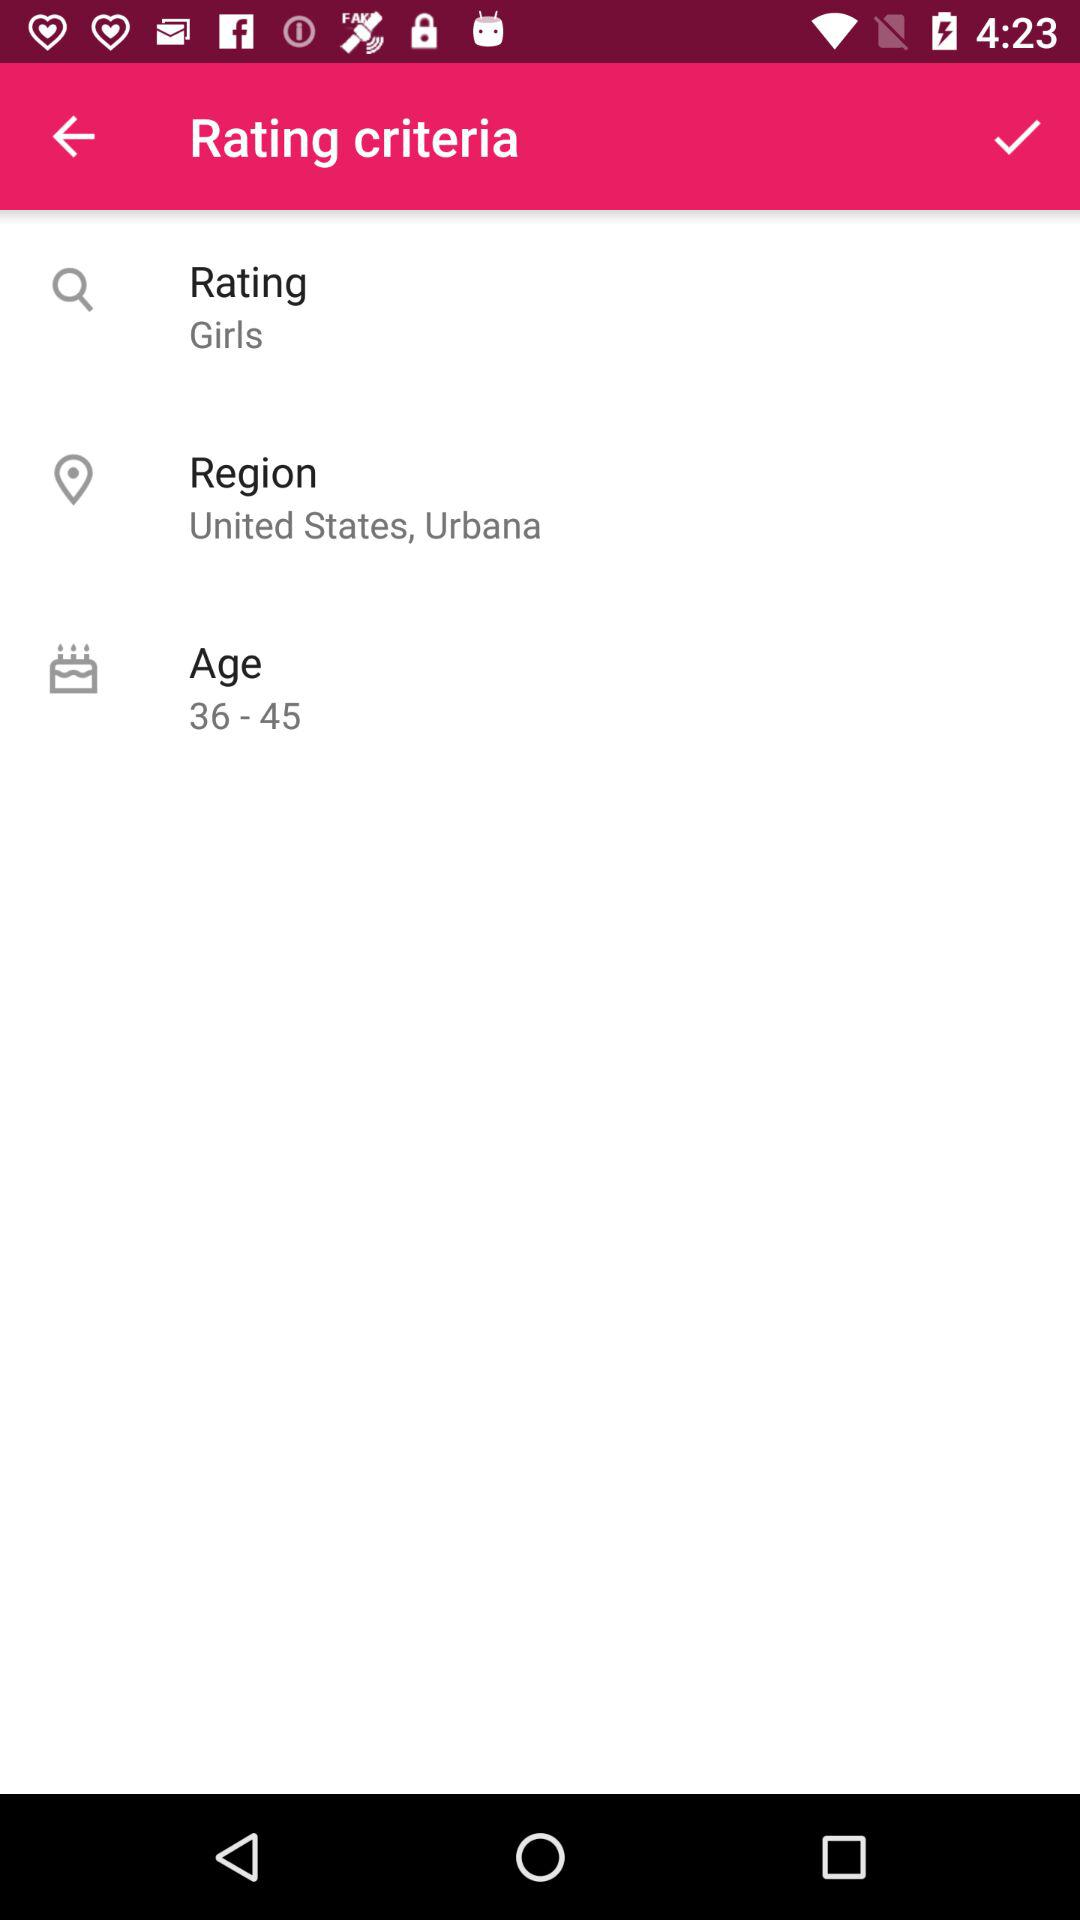How many more criteria are there than age options?
Answer the question using a single word or phrase. 2 